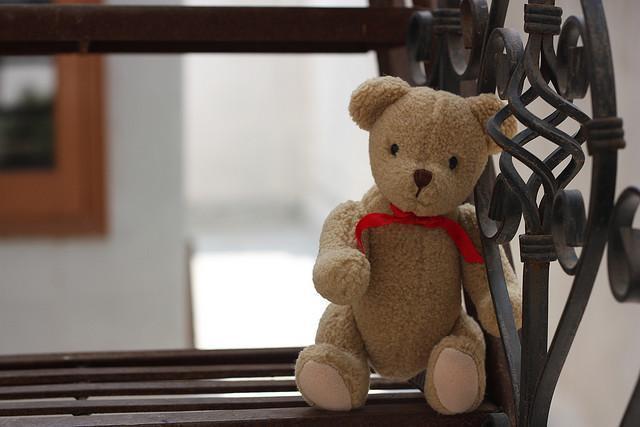How many slices of pizza are there?
Give a very brief answer. 0. 